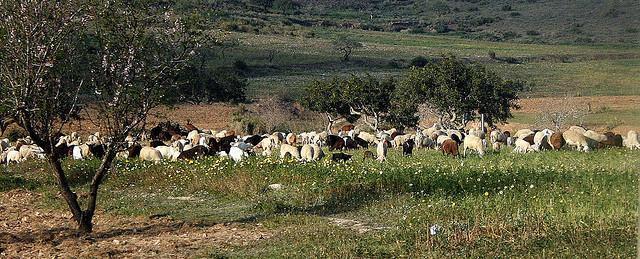How many sheep are there?
Give a very brief answer. 1. 